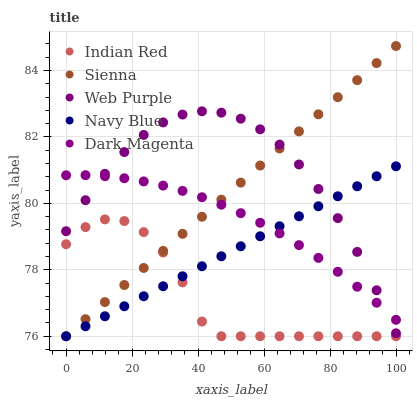Does Indian Red have the minimum area under the curve?
Answer yes or no. Yes. Does Web Purple have the maximum area under the curve?
Answer yes or no. Yes. Does Navy Blue have the minimum area under the curve?
Answer yes or no. No. Does Navy Blue have the maximum area under the curve?
Answer yes or no. No. Is Navy Blue the smoothest?
Answer yes or no. Yes. Is Indian Red the roughest?
Answer yes or no. Yes. Is Web Purple the smoothest?
Answer yes or no. No. Is Web Purple the roughest?
Answer yes or no. No. Does Sienna have the lowest value?
Answer yes or no. Yes. Does Web Purple have the lowest value?
Answer yes or no. No. Does Sienna have the highest value?
Answer yes or no. Yes. Does Navy Blue have the highest value?
Answer yes or no. No. Is Indian Red less than Web Purple?
Answer yes or no. Yes. Is Dark Magenta greater than Indian Red?
Answer yes or no. Yes. Does Sienna intersect Web Purple?
Answer yes or no. Yes. Is Sienna less than Web Purple?
Answer yes or no. No. Is Sienna greater than Web Purple?
Answer yes or no. No. Does Indian Red intersect Web Purple?
Answer yes or no. No. 